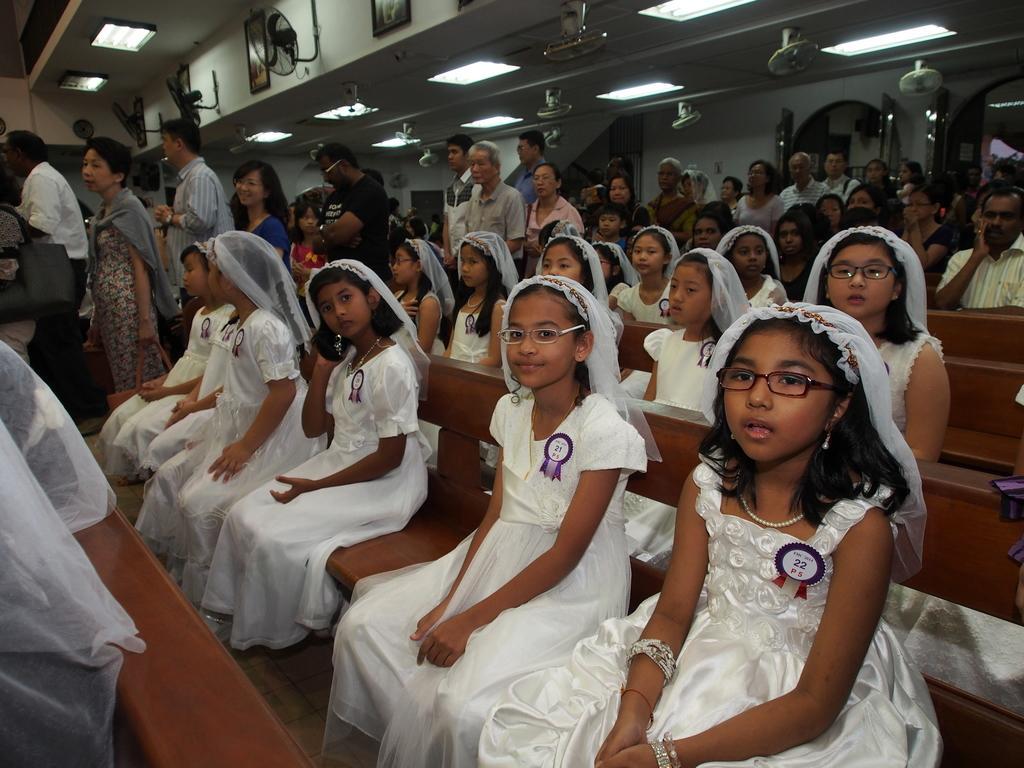In one or two sentences, can you explain what this image depicts? In this image we can see many girls wearing white frock are sitting on the wooden benches and these people standing here. In the background, we can see photo frames and fans on the wall and lights to the ceiling. 